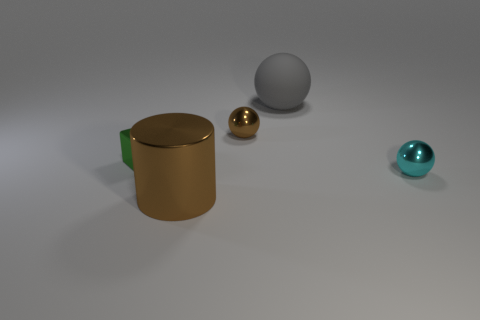Subtract all metallic spheres. How many spheres are left? 1 Add 4 big gray balls. How many objects exist? 9 Subtract all cyan spheres. How many spheres are left? 2 Subtract 1 cubes. How many cubes are left? 0 Subtract all blocks. How many objects are left? 4 Subtract 0 yellow cylinders. How many objects are left? 5 Subtract all gray balls. Subtract all yellow cylinders. How many balls are left? 2 Subtract all blue matte blocks. Subtract all large gray objects. How many objects are left? 4 Add 4 cubes. How many cubes are left? 5 Add 2 large matte spheres. How many large matte spheres exist? 3 